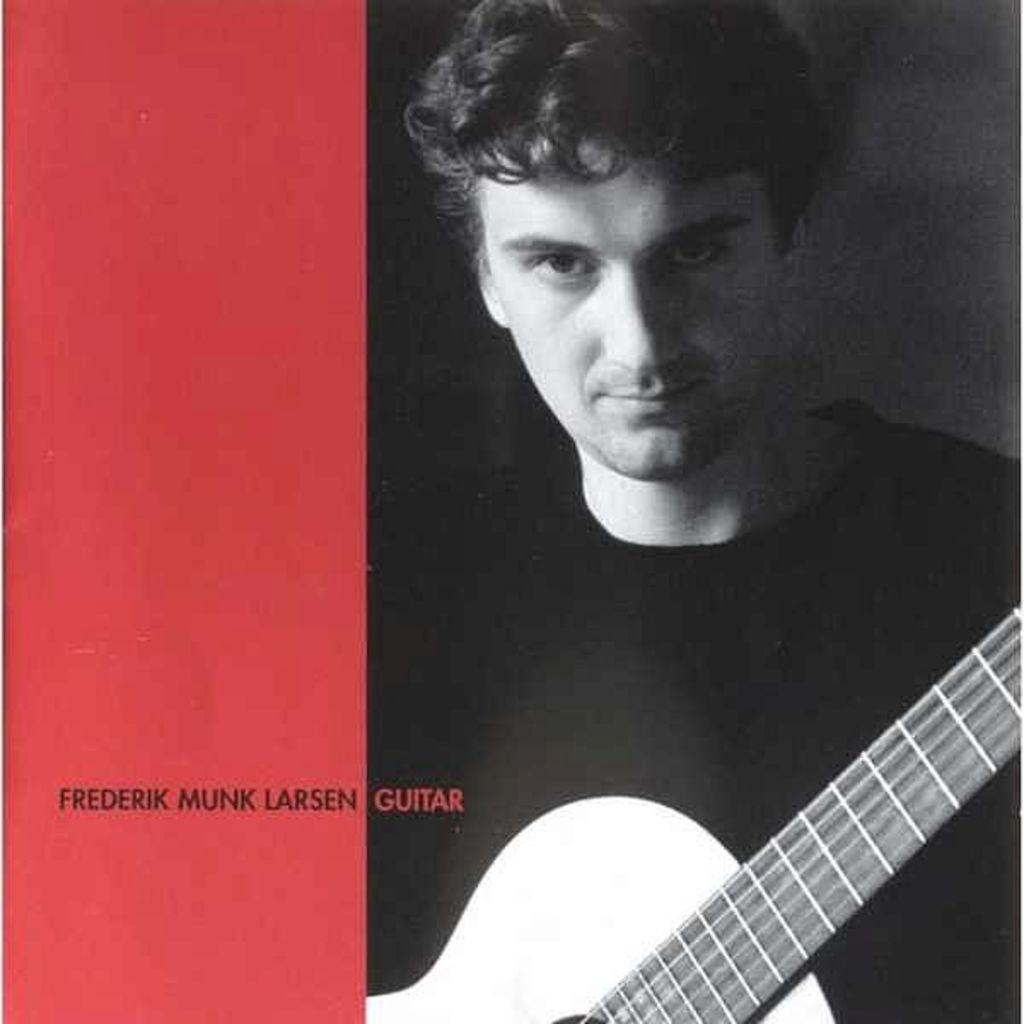What type of visual is the image? The image is a poster. What can be seen on the right side of the poster? There is a person with a guitar on the right side of the poster. What color is present on the left side of the poster? There is red color on the left side of the poster. What is written on the red color on the left side of the poster? There is text written on the red color on the left side of the poster. What type of linen is draped over the guitar in the image? There is no linen draped over the guitar in the image; it only shows a person holding a guitar. 